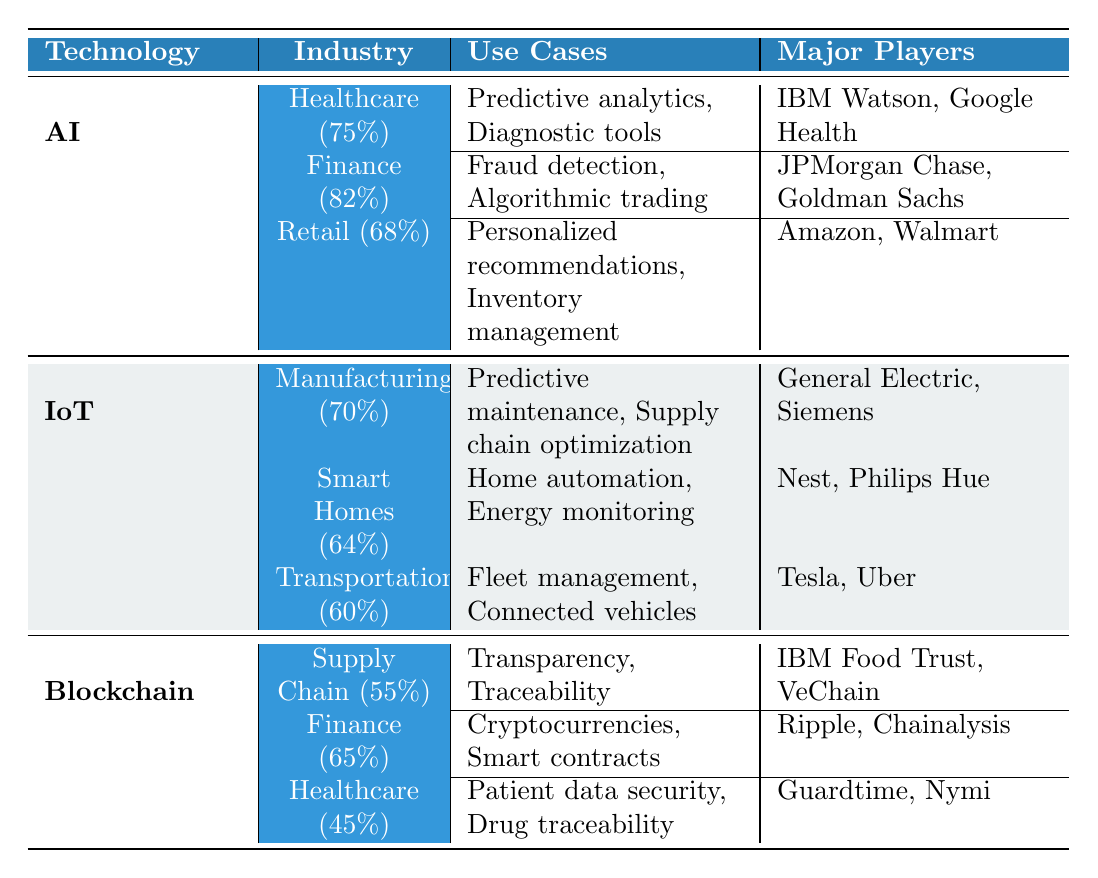What is the adoption rate of AI in Finance? The table lists the adoption rate of AI in Finance as 82%.
Answer: 82% Which industry has the highest adoption rate for AI? According to the table, Finance has the highest adoption rate for AI at 82%.
Answer: Finance What are the use cases for IoT in Smart Homes? The table specifies the use cases for IoT in Smart Homes as home automation and energy monitoring.
Answer: Home automation, energy monitoring True or False: The adoption rate of Blockchain in Supply Chain is higher than that in Healthcare. The table shows that the adoption rate of Blockchain in Supply Chain is 55% and in Healthcare is 45%, thus the statement is true.
Answer: True What is the average adoption rate of IoT across its three industries? The adoption rates for IoT are 70%, 64%, and 60%. Adding these rates gives 70 + 64 + 60 = 194, dividing by 3 results in an average of 64.67%.
Answer: 64.67% List the major players in the Retail industry for AI. The table shows that the major players in the Retail industry for AI are Amazon and Walmart.
Answer: Amazon, Walmart Which technology has the lowest adoption rate in the Healthcare sector? The adoption rates in the Healthcare sector are 75% for AI, 45% for Blockchain, resulting in Blockchain having the lowest adoption rate.
Answer: Blockchain Is the adoption rate of AI in Retail greater than the adoption rate of IoT in Smart Homes? The adoption rate for AI in Retail is 68% and for IoT in Smart Homes is 64%. Since 68% is greater than 64%, the answer is yes.
Answer: Yes What are the use cases for Blockchain in Finance? The table lists the use cases for Blockchain in Finance as cryptocurrencies and smart contracts.
Answer: Cryptocurrencies, smart contracts Which technology is most widely adopted in Healthcare? The table indicates the adoption rates for AI in Healthcare is 75%, whereas Blockchain is at 45%. Therefore, AI is the most adopted technology in Healthcare.
Answer: AI 